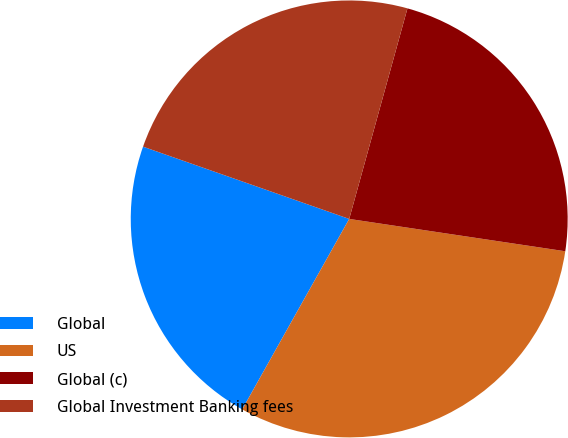Convert chart to OTSL. <chart><loc_0><loc_0><loc_500><loc_500><pie_chart><fcel>Global<fcel>US<fcel>Global (c)<fcel>Global Investment Banking fees<nl><fcel>22.22%<fcel>30.78%<fcel>23.07%<fcel>23.93%<nl></chart> 